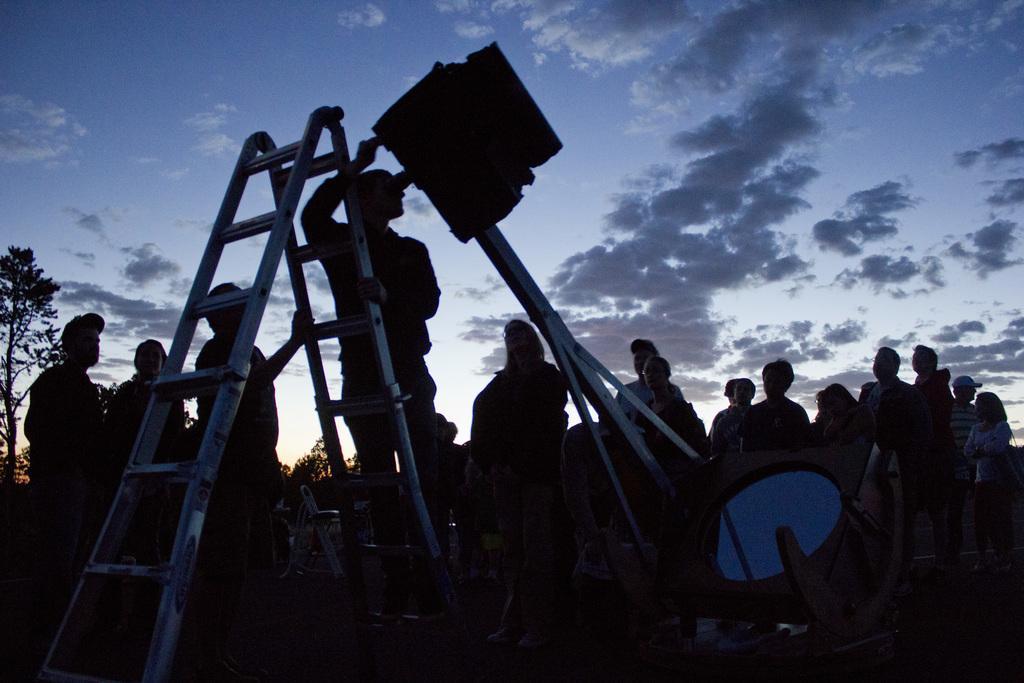Describe this image in one or two sentences. In this image we can see people. There is a ladder. In the background of the image there is sky, trees. 